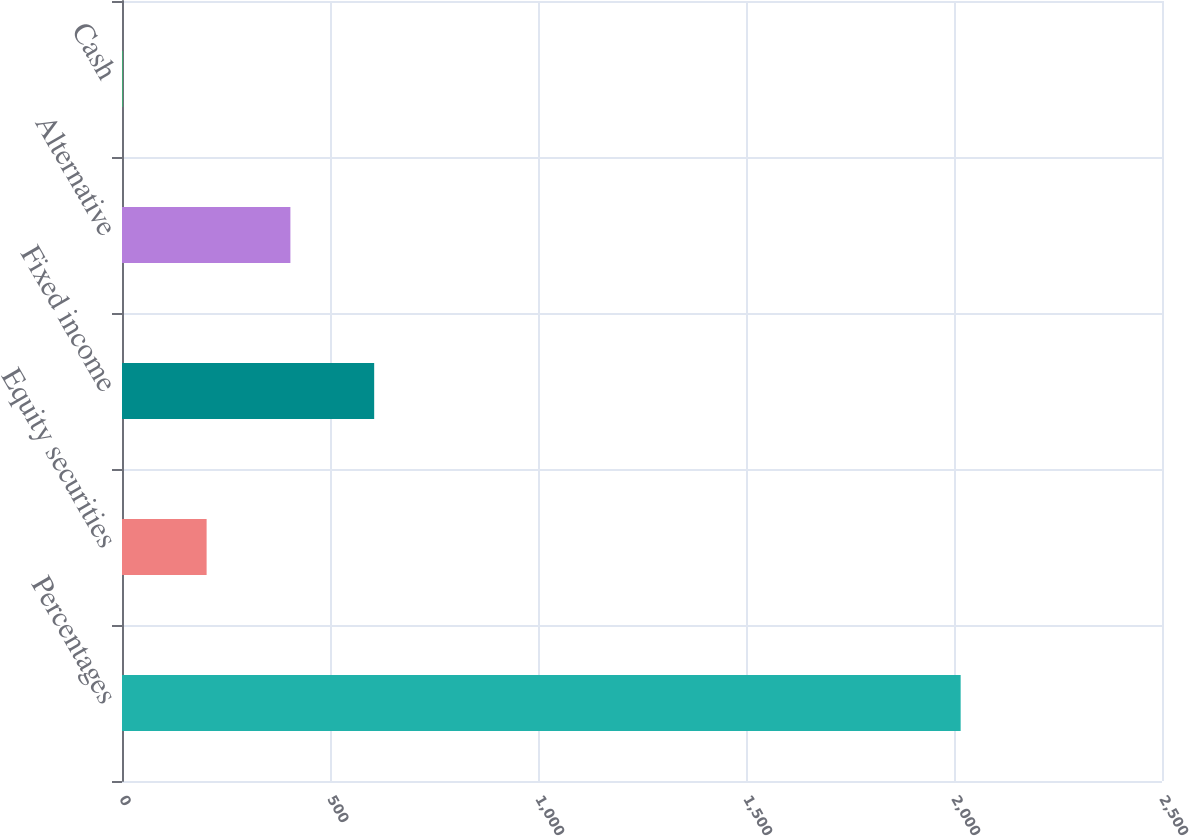<chart> <loc_0><loc_0><loc_500><loc_500><bar_chart><fcel>Percentages<fcel>Equity securities<fcel>Fixed income<fcel>Alternative<fcel>Cash<nl><fcel>2016<fcel>203.4<fcel>606.2<fcel>404.8<fcel>2<nl></chart> 